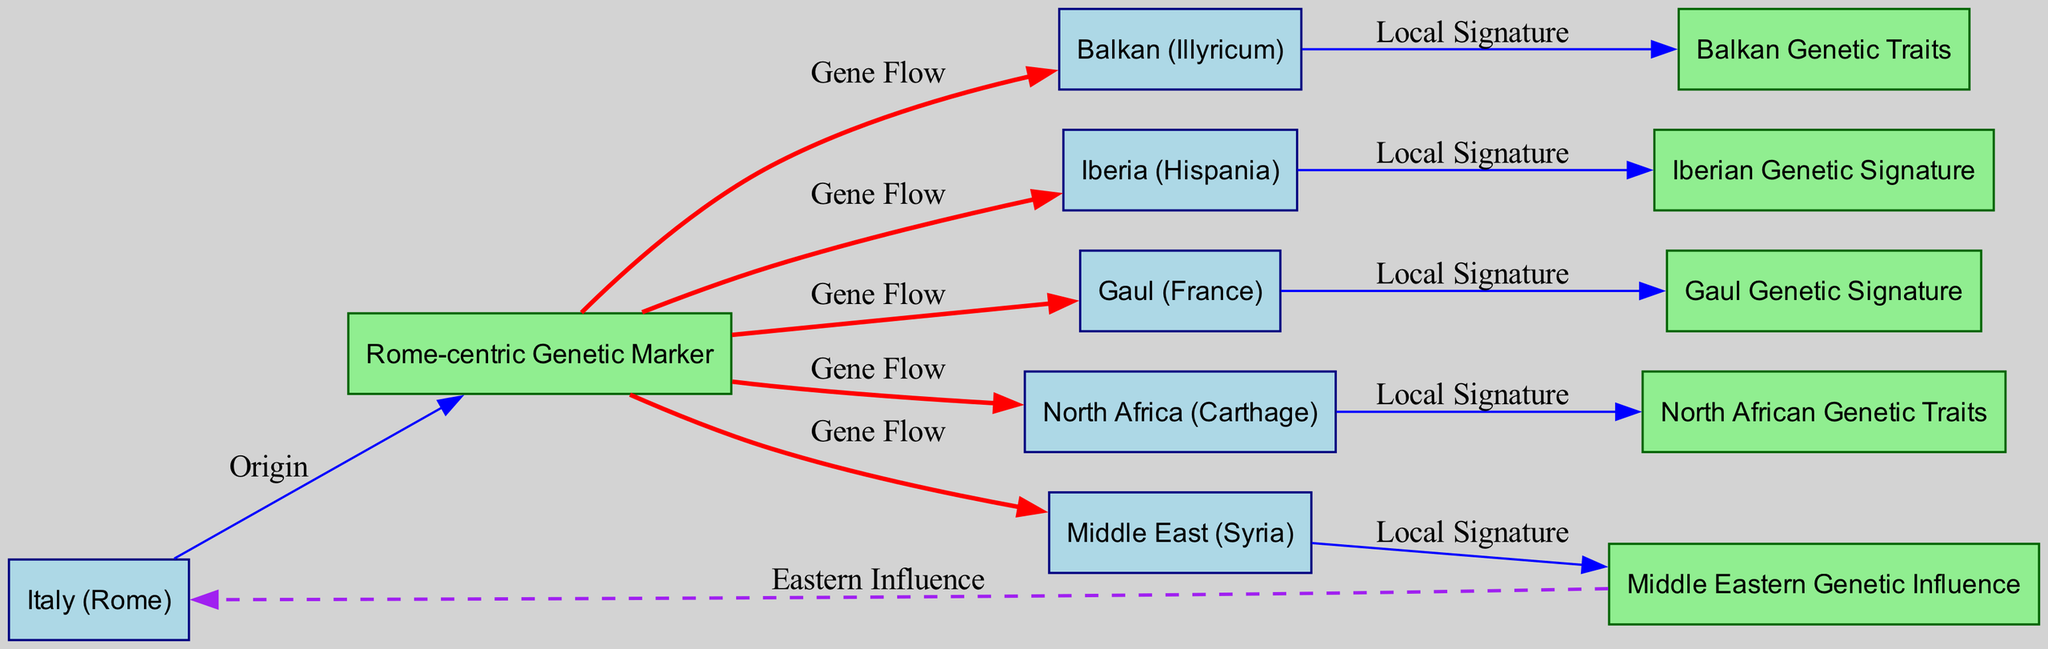What regions exhibit gene flow from the Roman-centric genetic marker? To answer this, we examine the edges originating from the "Rome-centric Genetic Marker" node. The diagram indicates gene flow to the nodes representing Iberia, Gaul, North Africa, Middle East, and Balkan.
Answer: Iberia, Gaul, North Africa, Middle East, Balkan How many regions are depicted in this diagram? The diagram contains a total of six regions: Italy, Iberia, Gaul, North Africa, Middle East, and Balkan. By counting these nodes, we confirm we have six distinct regions.
Answer: 6 Which region has a local genetic signature corresponding to Iberia? The diagram explicitly connects the "Iberia (Hispania)" node to the "Iberian Genetic Signature" node through a labeled edge "Local Signature". Thus, Iberia corresponds to its local genetic signature.
Answer: Iberia What type of influence is indicated between the Middle Eastern genetic markers and Italy? The edge between "Middle Eastern Genetic Influence" and "Italy (Rome)" is labeled as "Eastern Influence". This suggests a distinct connection characterized by a qualitative relationship rather than gene flow.
Answer: Eastern Influence What is the total number of gene flow edges in the diagram? By examining the edges specifically labeled as "Gene Flow", we find there are five such edges connecting the Rome-centric genetic marker to the other regional nodes, indicating the total number of gene flow connections.
Answer: 5 